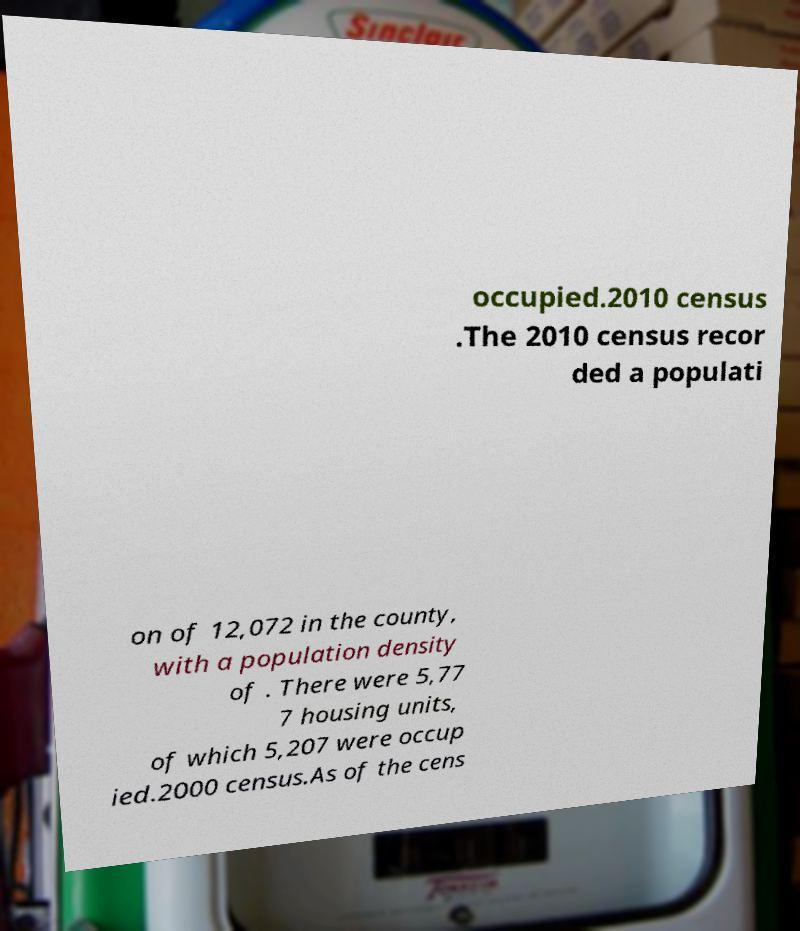Could you assist in decoding the text presented in this image and type it out clearly? occupied.2010 census .The 2010 census recor ded a populati on of 12,072 in the county, with a population density of . There were 5,77 7 housing units, of which 5,207 were occup ied.2000 census.As of the cens 